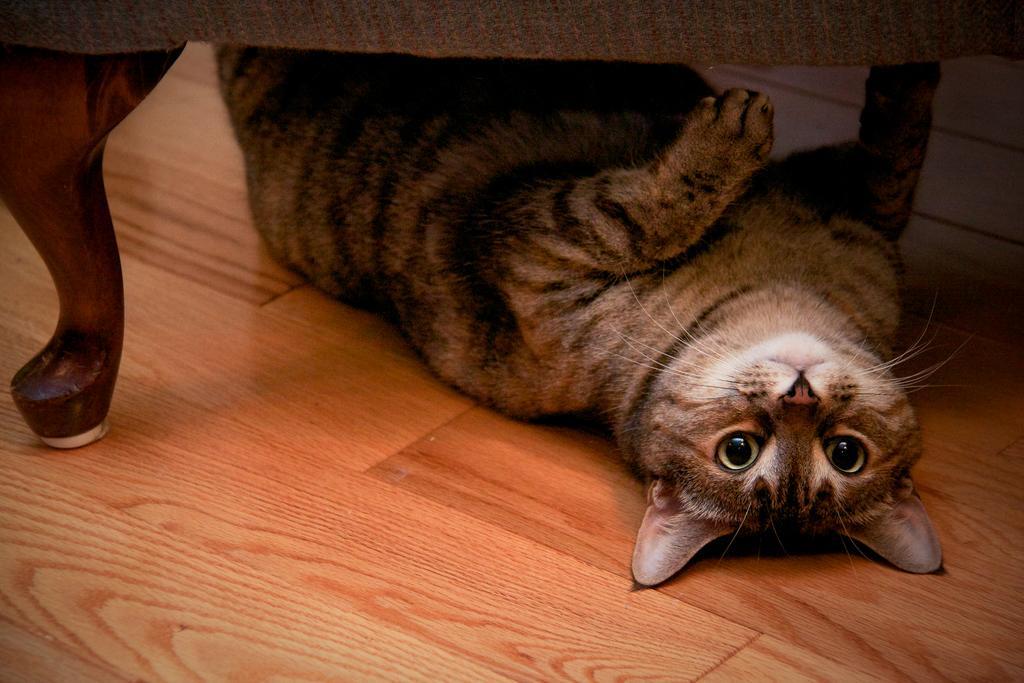In one or two sentences, can you explain what this image depicts? In this image, we can see a cat lying under the table. 